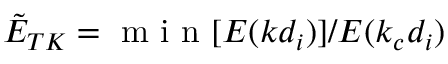Convert formula to latex. <formula><loc_0><loc_0><loc_500><loc_500>\tilde { E } _ { T K } = m i n [ E ( k d _ { i } ) ] / E ( k _ { c } d _ { i } )</formula> 